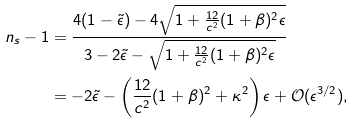Convert formula to latex. <formula><loc_0><loc_0><loc_500><loc_500>n _ { s } - 1 & = \frac { 4 ( 1 - \tilde { \epsilon } ) - 4 \sqrt { 1 + \frac { 1 2 } { c ^ { 2 } } ( 1 + \beta ) ^ { 2 } \epsilon } } { 3 - 2 \tilde { \epsilon } - \sqrt { 1 + \frac { 1 2 } { c ^ { 2 } } ( 1 + \beta ) ^ { 2 } \epsilon } } \\ & = - 2 \tilde { \epsilon } - \left ( \frac { 1 2 } { c ^ { 2 } } ( 1 + \beta ) ^ { 2 } + \kappa ^ { 2 } \right ) \epsilon + \mathcal { O } ( \epsilon ^ { 3 / 2 } ) ,</formula> 